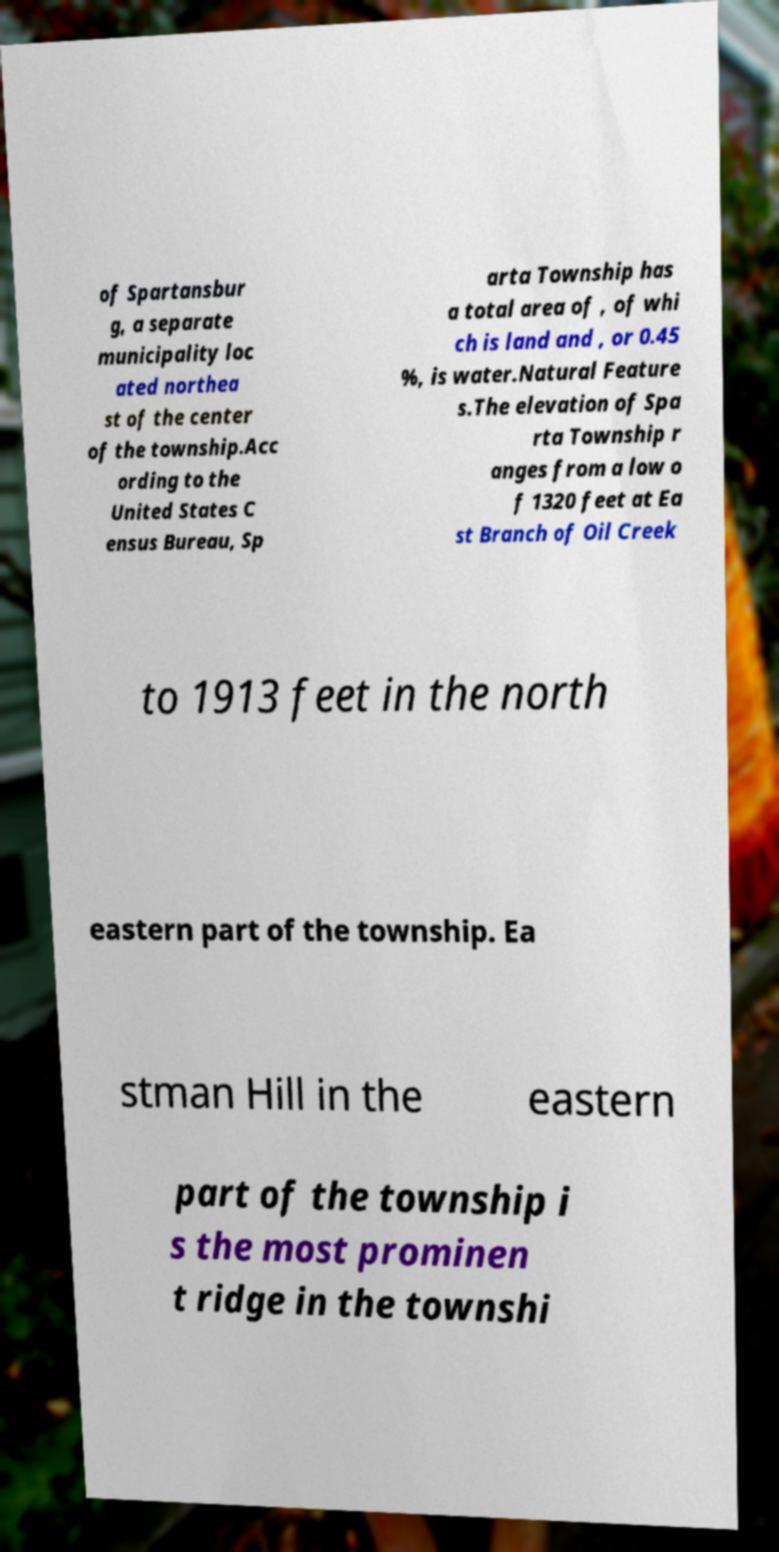For documentation purposes, I need the text within this image transcribed. Could you provide that? of Spartansbur g, a separate municipality loc ated northea st of the center of the township.Acc ording to the United States C ensus Bureau, Sp arta Township has a total area of , of whi ch is land and , or 0.45 %, is water.Natural Feature s.The elevation of Spa rta Township r anges from a low o f 1320 feet at Ea st Branch of Oil Creek to 1913 feet in the north eastern part of the township. Ea stman Hill in the eastern part of the township i s the most prominen t ridge in the townshi 